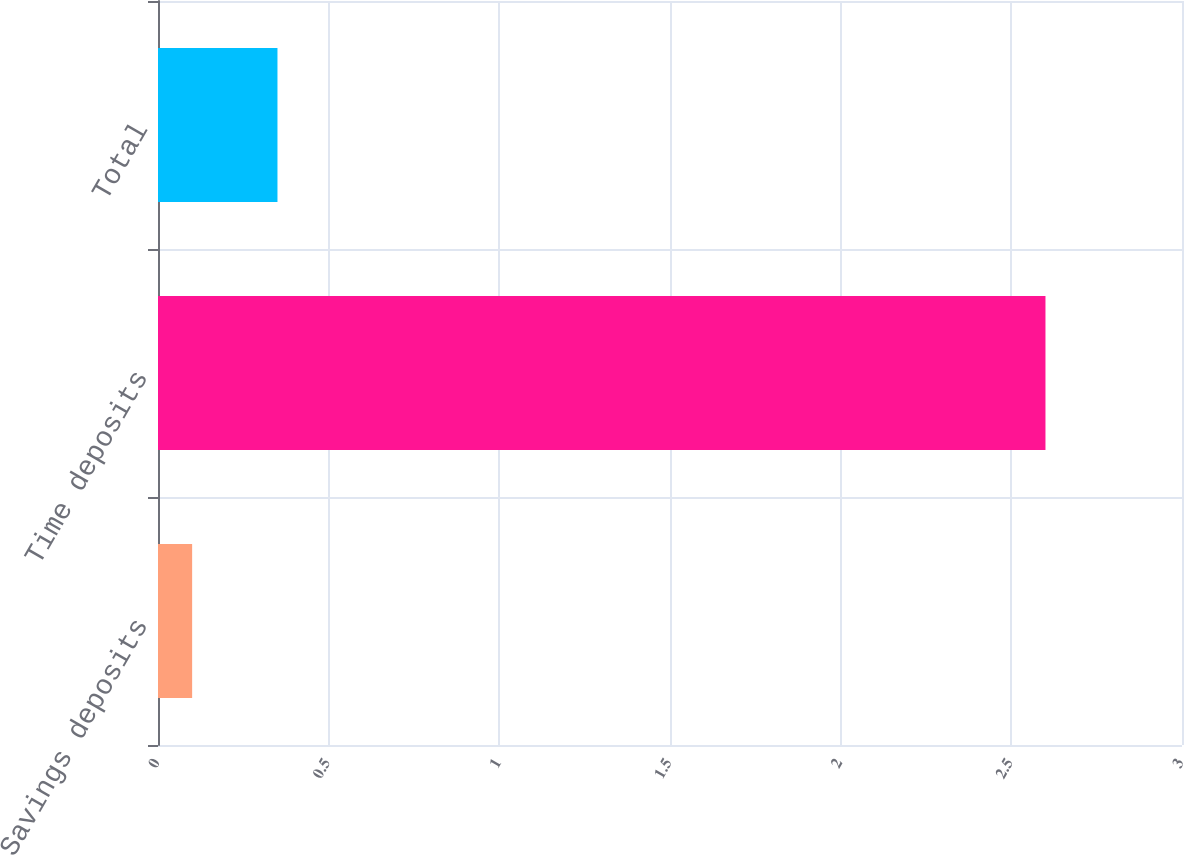Convert chart to OTSL. <chart><loc_0><loc_0><loc_500><loc_500><bar_chart><fcel>Savings deposits<fcel>Time deposits<fcel>Total<nl><fcel>0.1<fcel>2.6<fcel>0.35<nl></chart> 